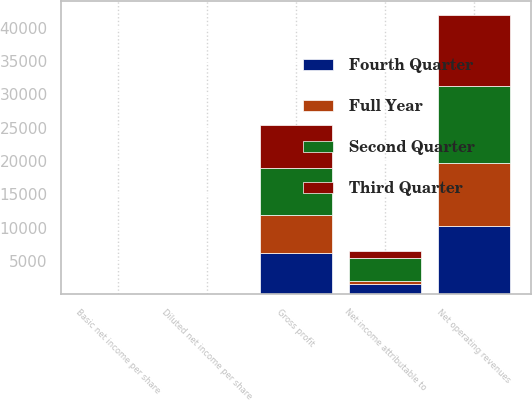<chart> <loc_0><loc_0><loc_500><loc_500><stacked_bar_chart><ecel><fcel>Net operating revenues<fcel>Gross profit<fcel>Net income attributable to<fcel>Basic net income per share<fcel>Diluted net income per share<nl><fcel>Fourth Quarter<fcel>10282<fcel>6213<fcel>1483<fcel>0.34<fcel>0.34<nl><fcel>Second Quarter<fcel>11539<fcel>7068<fcel>3448<fcel>0.8<fcel>0.79<nl><fcel>Third Quarter<fcel>10633<fcel>6502<fcel>1046<fcel>0.24<fcel>0.24<nl><fcel>Full Year<fcel>9409<fcel>5615<fcel>550<fcel>0.13<fcel>0.13<nl></chart> 